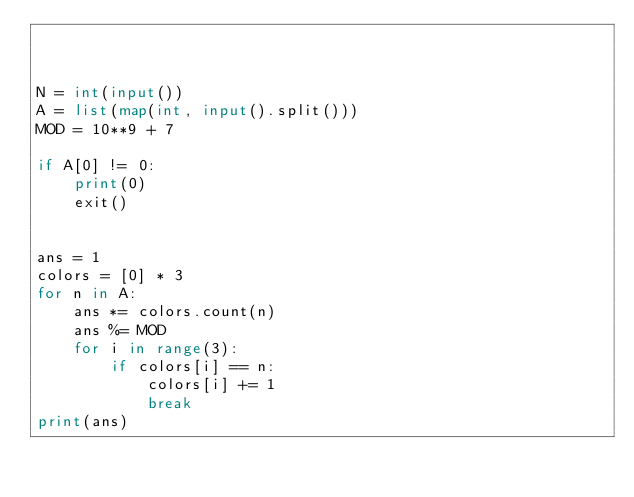Convert code to text. <code><loc_0><loc_0><loc_500><loc_500><_Python_>


N = int(input())
A = list(map(int, input().split()))
MOD = 10**9 + 7

if A[0] != 0:
    print(0)
    exit()


ans = 1
colors = [0] * 3
for n in A:
    ans *= colors.count(n)
    ans %= MOD
    for i in range(3):
        if colors[i] == n:
            colors[i] += 1
            break
print(ans)
</code> 